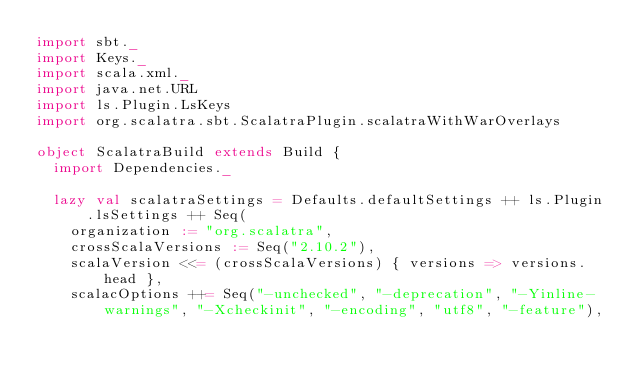Convert code to text. <code><loc_0><loc_0><loc_500><loc_500><_Scala_>import sbt._
import Keys._
import scala.xml._
import java.net.URL
import ls.Plugin.LsKeys
import org.scalatra.sbt.ScalatraPlugin.scalatraWithWarOverlays

object ScalatraBuild extends Build {
  import Dependencies._

  lazy val scalatraSettings = Defaults.defaultSettings ++ ls.Plugin.lsSettings ++ Seq(
    organization := "org.scalatra",
    crossScalaVersions := Seq("2.10.2"),
    scalaVersion <<= (crossScalaVersions) { versions => versions.head },
    scalacOptions ++= Seq("-unchecked", "-deprecation", "-Yinline-warnings", "-Xcheckinit", "-encoding", "utf8", "-feature"),</code> 